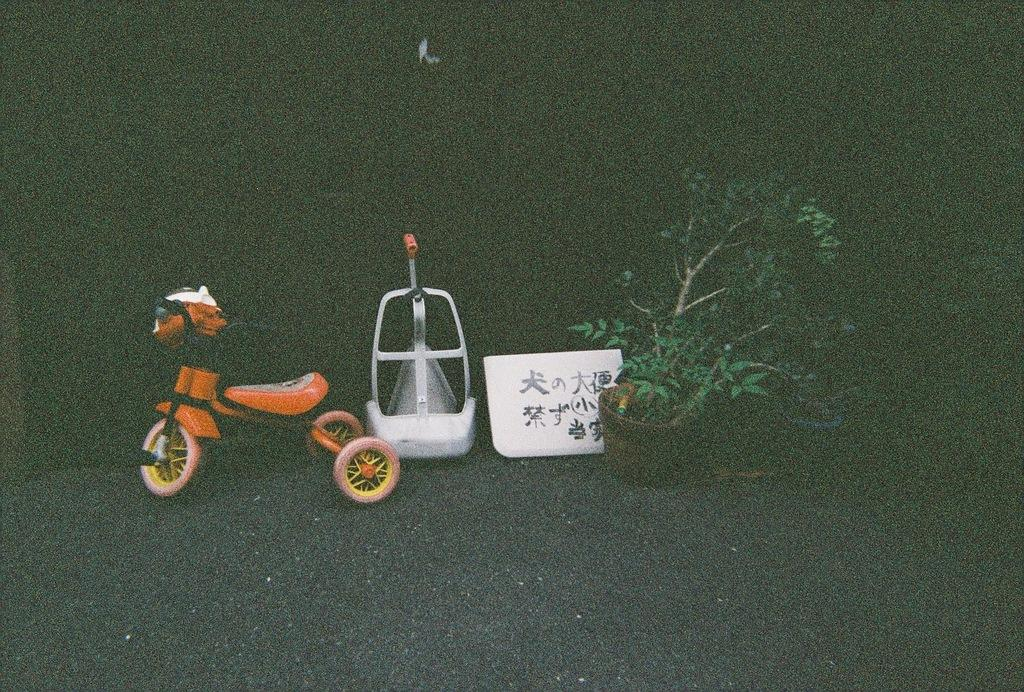What type of vehicle is in the image? There is a tricycle in the image. What type of plant can be seen in the image? There is a potted plant in the image. What is written on the board in the image? There is a board with text in the image. What color is the white object in the image? The white object in the image is white. How would you describe the background of the image? The background of the image is dark. What type of mass is being conducted in the image? There is no indication of a mass or any religious ceremony in the image. What type of plants are growing in the image? The image only shows a potted plant, not a variety of plants growing. 